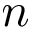Convert formula to latex. <formula><loc_0><loc_0><loc_500><loc_500>n</formula> 